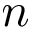Convert formula to latex. <formula><loc_0><loc_0><loc_500><loc_500>n</formula> 